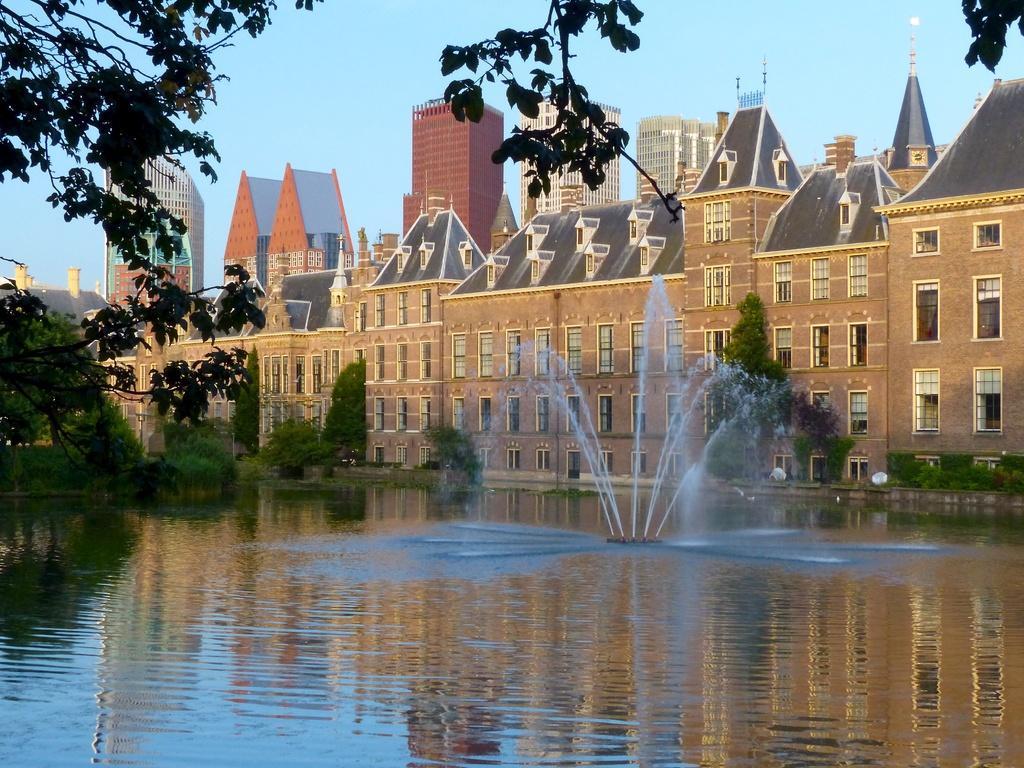Can you describe this image briefly? In this image there are buildings in the background. At the bottom there is water and there is a fountain in the water. On the left side there are trees near the buildings. At the top there is sky. 